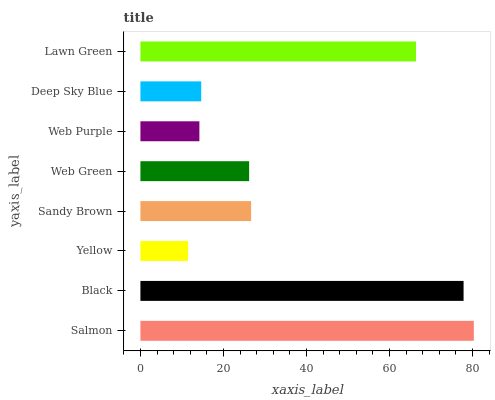Is Yellow the minimum?
Answer yes or no. Yes. Is Salmon the maximum?
Answer yes or no. Yes. Is Black the minimum?
Answer yes or no. No. Is Black the maximum?
Answer yes or no. No. Is Salmon greater than Black?
Answer yes or no. Yes. Is Black less than Salmon?
Answer yes or no. Yes. Is Black greater than Salmon?
Answer yes or no. No. Is Salmon less than Black?
Answer yes or no. No. Is Sandy Brown the high median?
Answer yes or no. Yes. Is Web Green the low median?
Answer yes or no. Yes. Is Black the high median?
Answer yes or no. No. Is Lawn Green the low median?
Answer yes or no. No. 